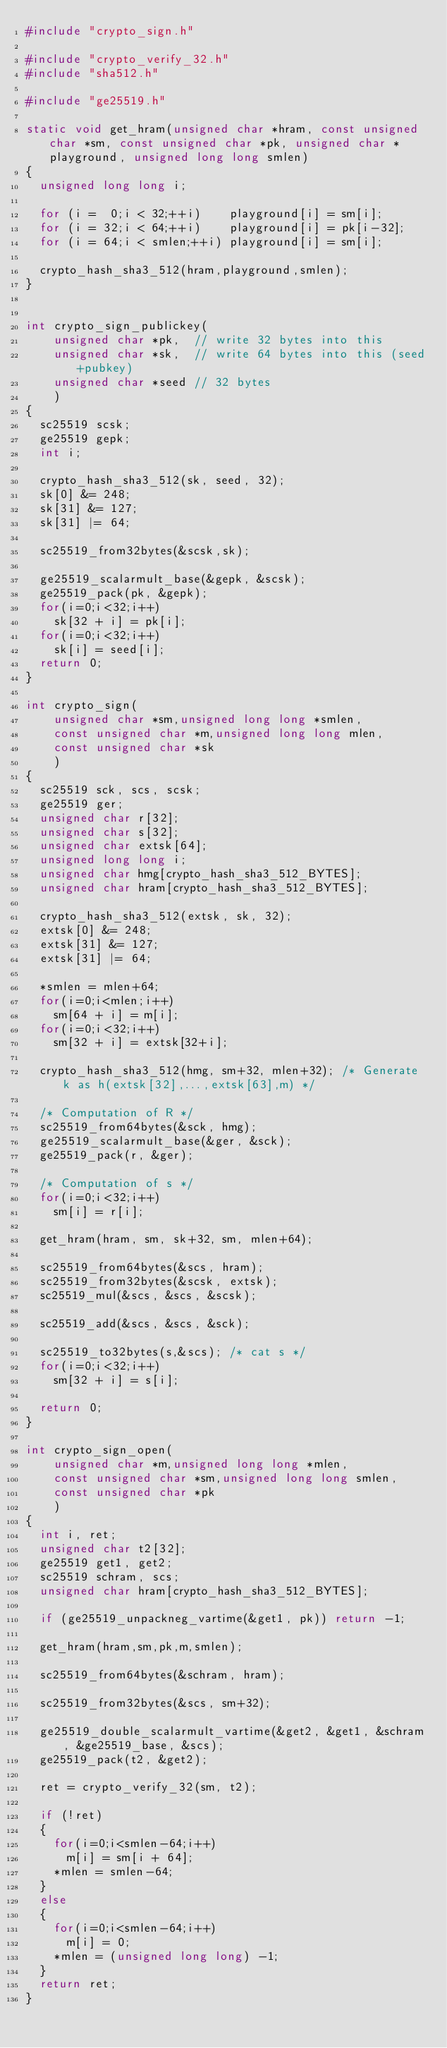Convert code to text. <code><loc_0><loc_0><loc_500><loc_500><_C_>#include "crypto_sign.h"

#include "crypto_verify_32.h"
#include "sha512.h"

#include "ge25519.h"

static void get_hram(unsigned char *hram, const unsigned char *sm, const unsigned char *pk, unsigned char *playground, unsigned long long smlen)
{
  unsigned long long i;

  for (i =  0;i < 32;++i)    playground[i] = sm[i];
  for (i = 32;i < 64;++i)    playground[i] = pk[i-32];
  for (i = 64;i < smlen;++i) playground[i] = sm[i];

  crypto_hash_sha3_512(hram,playground,smlen);
}


int crypto_sign_publickey(
    unsigned char *pk,  // write 32 bytes into this
    unsigned char *sk,  // write 64 bytes into this (seed+pubkey)
    unsigned char *seed // 32 bytes
    )
{
  sc25519 scsk;
  ge25519 gepk;
  int i;

  crypto_hash_sha3_512(sk, seed, 32);
  sk[0] &= 248;
  sk[31] &= 127;
  sk[31] |= 64;

  sc25519_from32bytes(&scsk,sk);

  ge25519_scalarmult_base(&gepk, &scsk);
  ge25519_pack(pk, &gepk);
  for(i=0;i<32;i++)
    sk[32 + i] = pk[i];
  for(i=0;i<32;i++)
    sk[i] = seed[i];
  return 0;
}

int crypto_sign(
    unsigned char *sm,unsigned long long *smlen,
    const unsigned char *m,unsigned long long mlen,
    const unsigned char *sk
    )
{
  sc25519 sck, scs, scsk;
  ge25519 ger;
  unsigned char r[32];
  unsigned char s[32];
  unsigned char extsk[64];
  unsigned long long i;
  unsigned char hmg[crypto_hash_sha3_512_BYTES];
  unsigned char hram[crypto_hash_sha3_512_BYTES];

  crypto_hash_sha3_512(extsk, sk, 32);
  extsk[0] &= 248;
  extsk[31] &= 127;
  extsk[31] |= 64;

  *smlen = mlen+64;
  for(i=0;i<mlen;i++)
    sm[64 + i] = m[i];
  for(i=0;i<32;i++)
    sm[32 + i] = extsk[32+i];

  crypto_hash_sha3_512(hmg, sm+32, mlen+32); /* Generate k as h(extsk[32],...,extsk[63],m) */

  /* Computation of R */
  sc25519_from64bytes(&sck, hmg);
  ge25519_scalarmult_base(&ger, &sck);
  ge25519_pack(r, &ger);

  /* Computation of s */
  for(i=0;i<32;i++)
    sm[i] = r[i];

  get_hram(hram, sm, sk+32, sm, mlen+64);

  sc25519_from64bytes(&scs, hram);
  sc25519_from32bytes(&scsk, extsk);
  sc25519_mul(&scs, &scs, &scsk);

  sc25519_add(&scs, &scs, &sck);

  sc25519_to32bytes(s,&scs); /* cat s */
  for(i=0;i<32;i++)
    sm[32 + i] = s[i];

  return 0;
}

int crypto_sign_open(
    unsigned char *m,unsigned long long *mlen,
    const unsigned char *sm,unsigned long long smlen,
    const unsigned char *pk
    )
{
  int i, ret;
  unsigned char t2[32];
  ge25519 get1, get2;
  sc25519 schram, scs;
  unsigned char hram[crypto_hash_sha3_512_BYTES];

  if (ge25519_unpackneg_vartime(&get1, pk)) return -1;

  get_hram(hram,sm,pk,m,smlen);

  sc25519_from64bytes(&schram, hram);

  sc25519_from32bytes(&scs, sm+32);

  ge25519_double_scalarmult_vartime(&get2, &get1, &schram, &ge25519_base, &scs);
  ge25519_pack(t2, &get2);

  ret = crypto_verify_32(sm, t2);

  if (!ret)
  {
    for(i=0;i<smlen-64;i++)
      m[i] = sm[i + 64];
    *mlen = smlen-64;
  }
  else
  {
    for(i=0;i<smlen-64;i++)
      m[i] = 0;
    *mlen = (unsigned long long) -1;
  }
  return ret;
}
</code> 